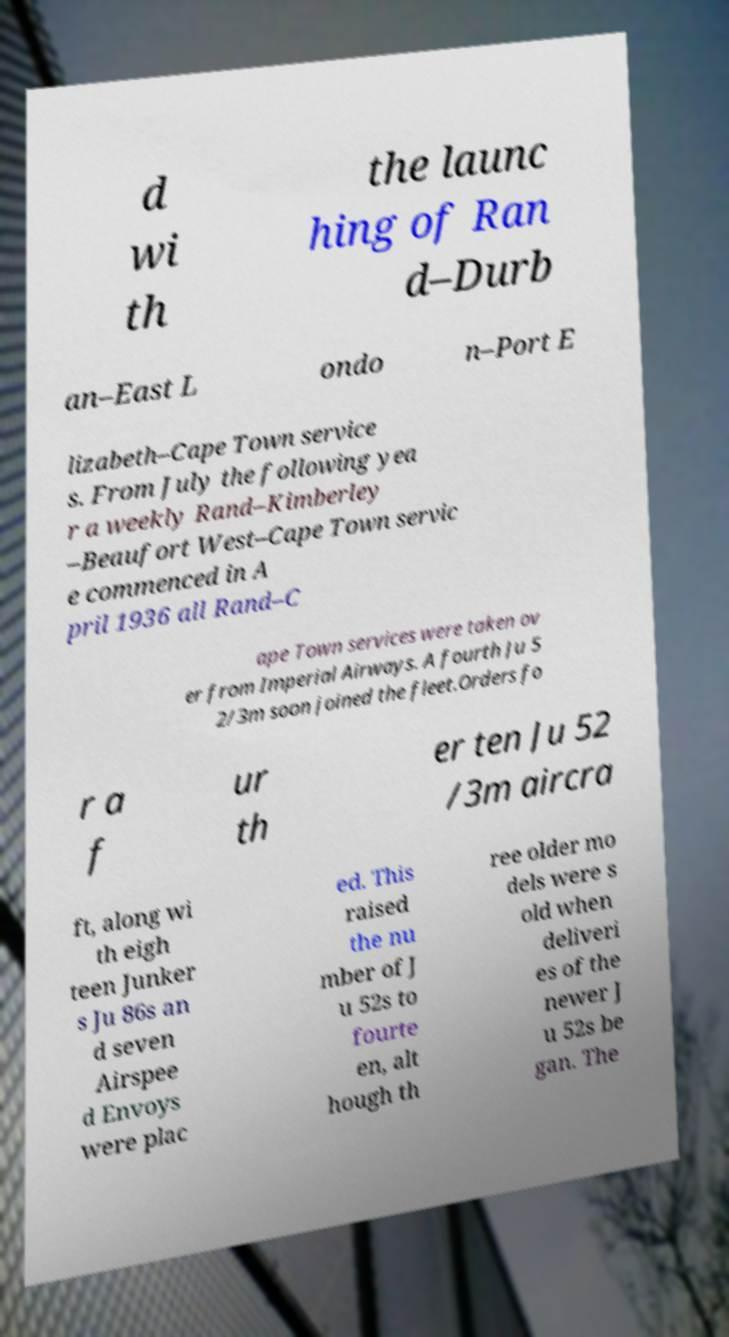Could you extract and type out the text from this image? d wi th the launc hing of Ran d–Durb an–East L ondo n–Port E lizabeth–Cape Town service s. From July the following yea r a weekly Rand–Kimberley –Beaufort West–Cape Town servic e commenced in A pril 1936 all Rand–C ape Town services were taken ov er from Imperial Airways. A fourth Ju 5 2/3m soon joined the fleet.Orders fo r a f ur th er ten Ju 52 /3m aircra ft, along wi th eigh teen Junker s Ju 86s an d seven Airspee d Envoys were plac ed. This raised the nu mber of J u 52s to fourte en, alt hough th ree older mo dels were s old when deliveri es of the newer J u 52s be gan. The 